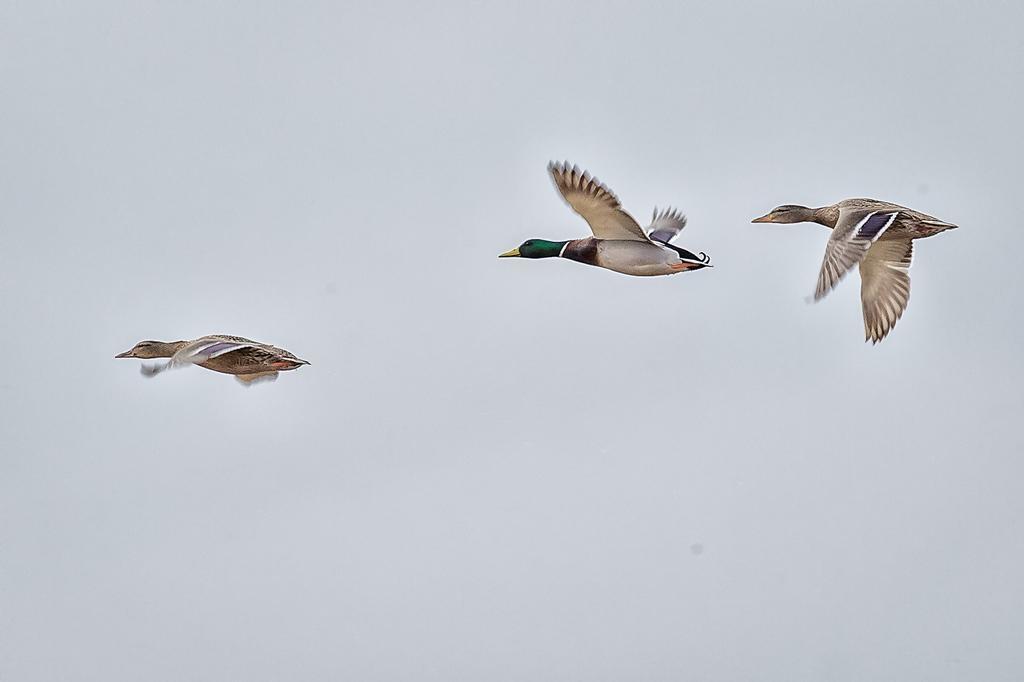Describe this image in one or two sentences. In this image we can see the birds flying in the air. In the background we can see the sky. 